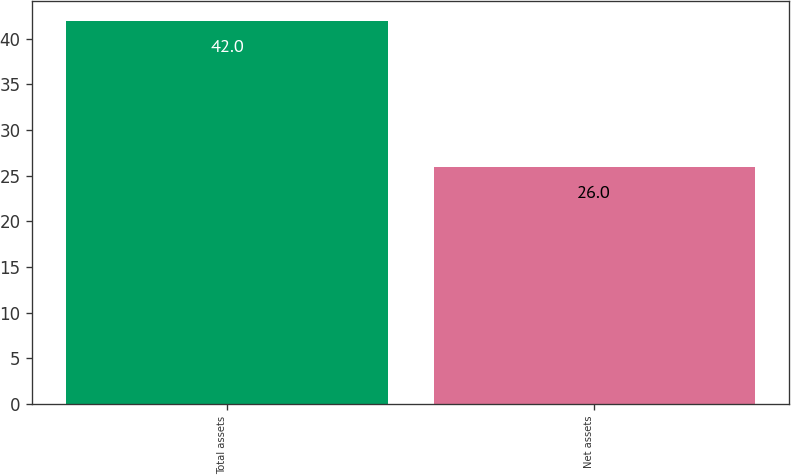Convert chart to OTSL. <chart><loc_0><loc_0><loc_500><loc_500><bar_chart><fcel>Total assets<fcel>Net assets<nl><fcel>42<fcel>26<nl></chart> 